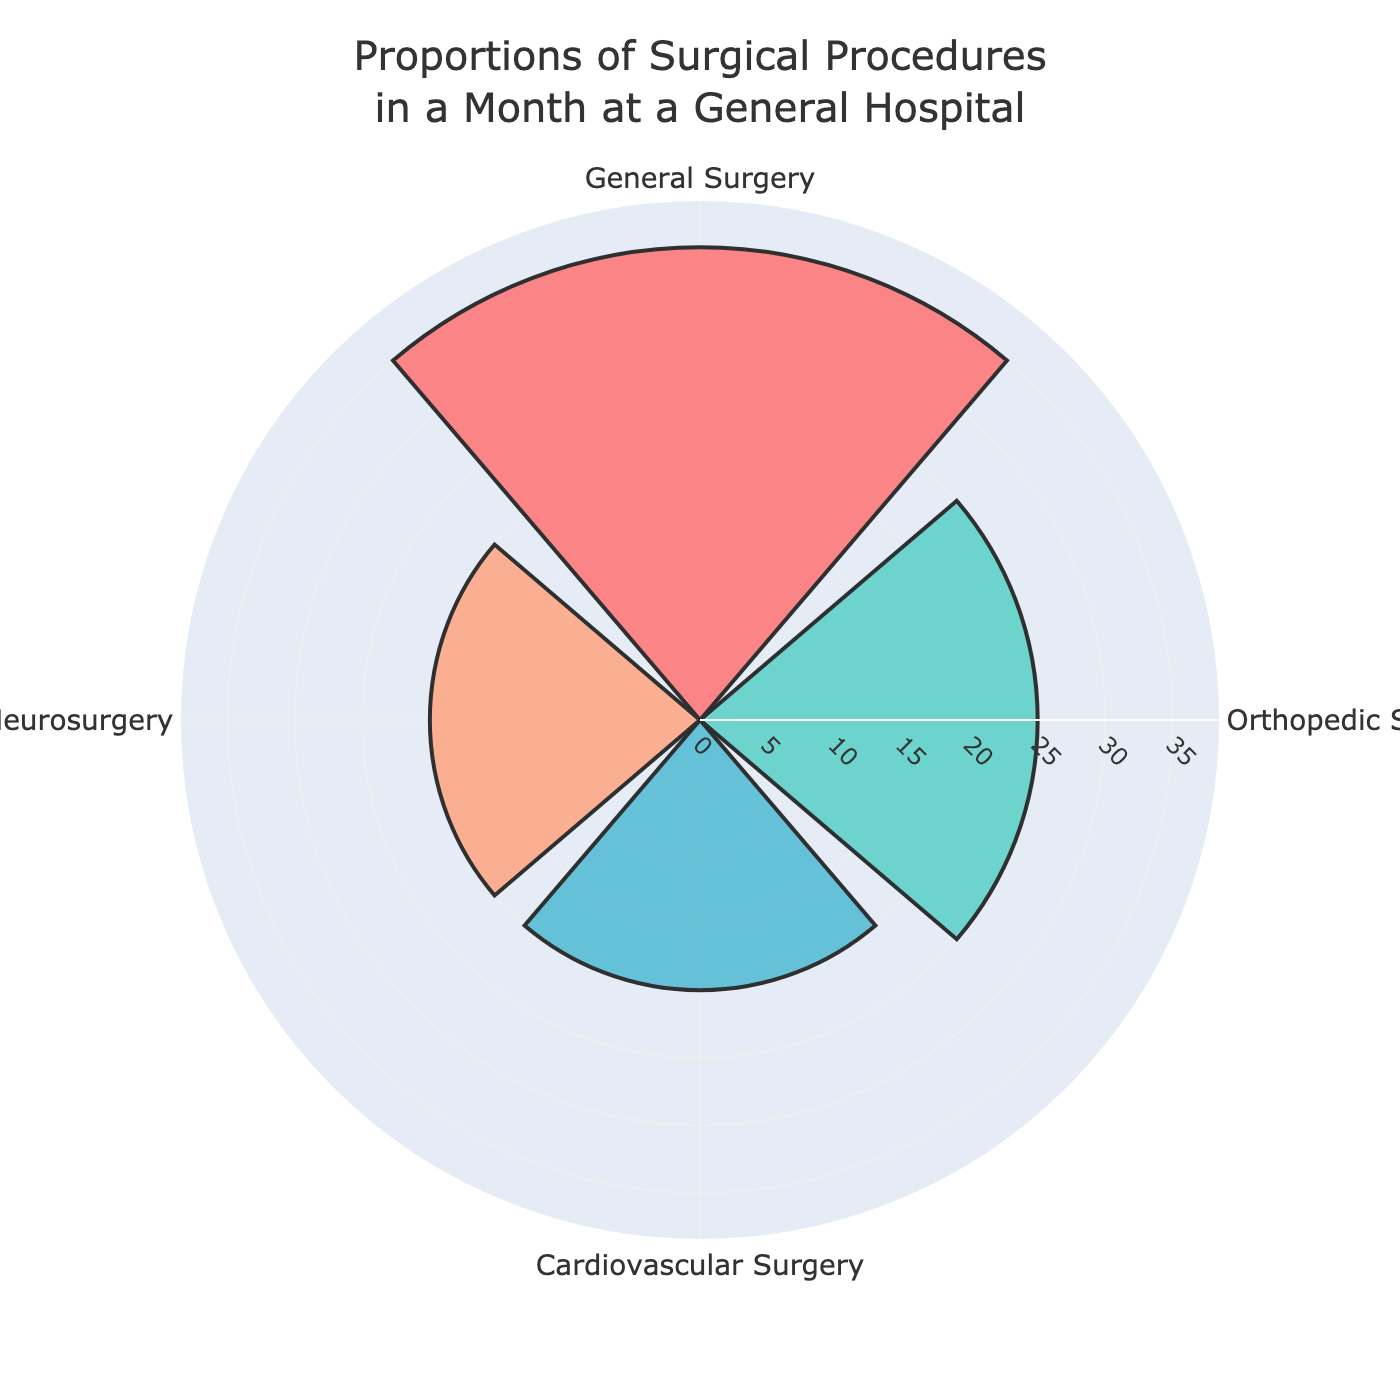What is the title of the rose chart? The title is displayed at the top of the rose chart, which reads "Proportions of Surgical Procedures in a Month at a General Hospital".
Answer: Proportions of Surgical Procedures in a Month at a General Hospital Which procedure has the highest percentage? By observing the length of the bars on the chart, we can see that the "General Surgery" bar is the longest, indicating it has the highest percentage.
Answer: General Surgery How many surgical procedures have the same percentage? Two groups, "Cardiovascular Surgery" and "Neurosurgery," have bars of the same length, indicating they both account for 20% each.
Answer: Two What is the combined percentage of Cardiovascular and Neurosurgery? Both Cardiovascular Surgery and Neurosurgery have a percentage of 20%. Adding these together gives 20% + 20%.
Answer: 40% Which procedure has a lower percentage than General Surgery but higher than Cardiovascular Surgery? General Surgery has 35%, Cardiovascular Surgery has 20%, and Orthopedic Surgery has 25%, which is in between the two.
Answer: Orthopedic Surgery What percentage of surgeries were either General Surgery or Orthopedic Surgery? General Surgery accounts for 35% and Orthopedic Surgery for 25%. Adding these percentages together gives 35% + 25%.
Answer: 60% Compare the percentage of General Surgery to the percentage of Orthopedic Surgery. Which is higher and by how much? General Surgery has 35% and Orthopedic Surgery has 25%. The difference between them is 35% - 25%.
Answer: General Surgery by 10% What is the least observed surgical procedure and its percentage? By examining the chart, both Cardiovascular Surgery and Neurosurgery have the smallest bars, each indicating 20%.
Answer: Cardiovascular Surgery and Neurosurgery at 20% If Neurosurgery were to increase by 5%, what would its new percentage be and would it still be the lowest? Neurosurgery currently has 20%. Adding 5% to this gives 20% + 5%. Even with this increase, its new percentage would be 25%, which matches Orthopedic Surgery and is still lower than General Surgery.
Answer: 25%, not the lowest 